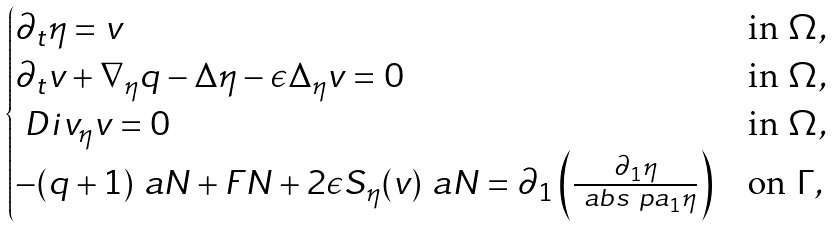Convert formula to latex. <formula><loc_0><loc_0><loc_500><loc_500>\begin{cases} \partial _ { t } \eta = v & \text {in } \Omega , \\ \partial _ { t } v + \nabla _ { \eta } q - \Delta \eta - \epsilon \Delta _ { \eta } v = 0 & \text {in } \Omega , \\ \ D i v _ { \eta } v = 0 & \text {in } \Omega , \\ - ( q + 1 ) \ a N + F N + 2 \epsilon S _ { \eta } ( v ) \ a N = \partial _ { 1 } \left ( \frac { \partial _ { 1 } \eta } { \ a b s { \ p a _ { 1 } \eta } } \right ) & \text {on } \Gamma , \end{cases}</formula> 